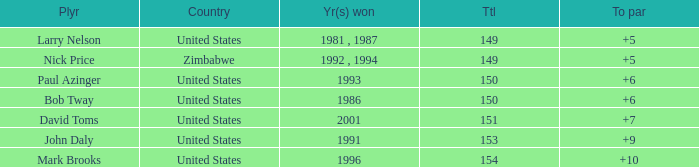Which player won in 1993? Paul Azinger. 